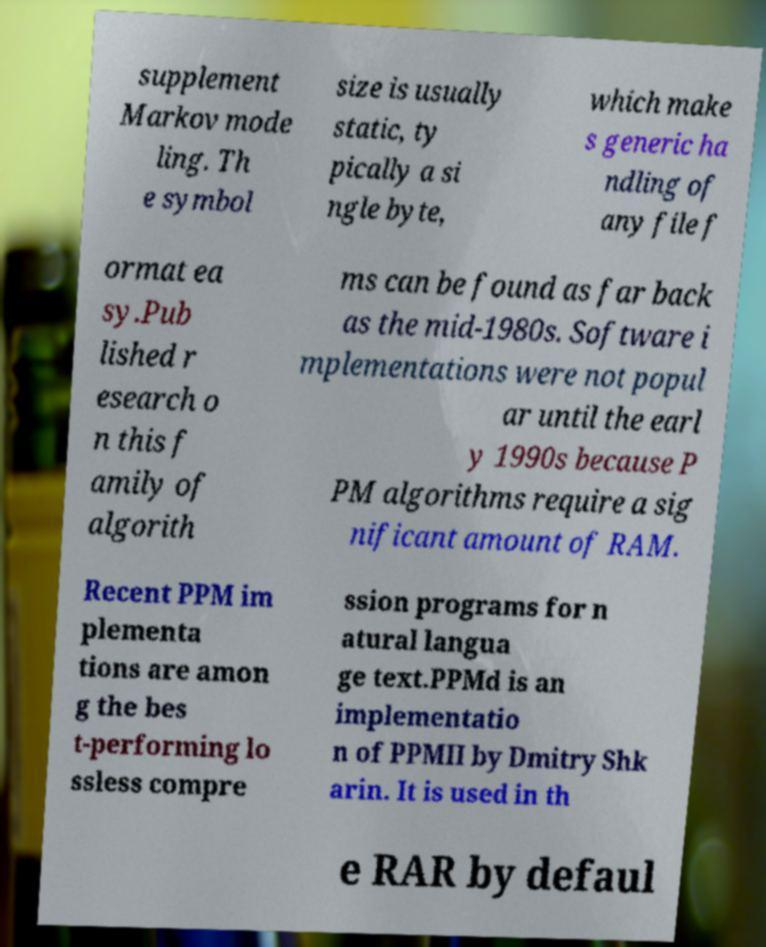For documentation purposes, I need the text within this image transcribed. Could you provide that? supplement Markov mode ling. Th e symbol size is usually static, ty pically a si ngle byte, which make s generic ha ndling of any file f ormat ea sy.Pub lished r esearch o n this f amily of algorith ms can be found as far back as the mid-1980s. Software i mplementations were not popul ar until the earl y 1990s because P PM algorithms require a sig nificant amount of RAM. Recent PPM im plementa tions are amon g the bes t-performing lo ssless compre ssion programs for n atural langua ge text.PPMd is an implementatio n of PPMII by Dmitry Shk arin. It is used in th e RAR by defaul 